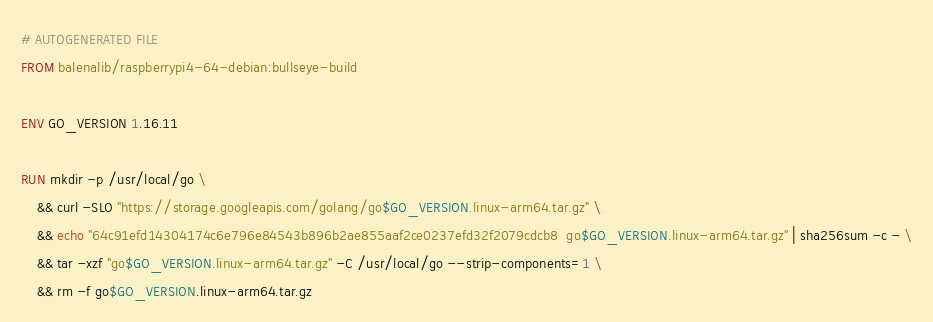<code> <loc_0><loc_0><loc_500><loc_500><_Dockerfile_># AUTOGENERATED FILE
FROM balenalib/raspberrypi4-64-debian:bullseye-build

ENV GO_VERSION 1.16.11

RUN mkdir -p /usr/local/go \
	&& curl -SLO "https://storage.googleapis.com/golang/go$GO_VERSION.linux-arm64.tar.gz" \
	&& echo "64c91efd14304174c6e796e84543b896b2ae855aaf2ce0237efd32f2079cdcb8  go$GO_VERSION.linux-arm64.tar.gz" | sha256sum -c - \
	&& tar -xzf "go$GO_VERSION.linux-arm64.tar.gz" -C /usr/local/go --strip-components=1 \
	&& rm -f go$GO_VERSION.linux-arm64.tar.gz
</code> 